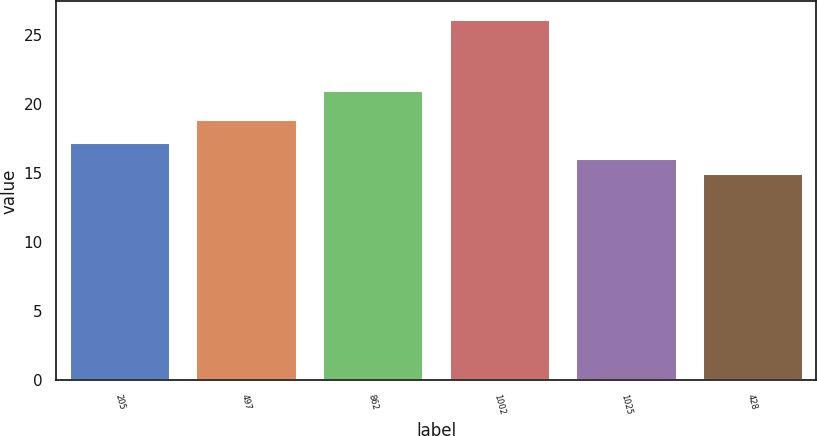Convert chart. <chart><loc_0><loc_0><loc_500><loc_500><bar_chart><fcel>205<fcel>497<fcel>862<fcel>1002<fcel>1025<fcel>428<nl><fcel>17.22<fcel>18.9<fcel>21<fcel>26.1<fcel>16.11<fcel>15<nl></chart> 